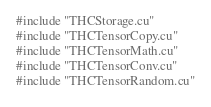<code> <loc_0><loc_0><loc_500><loc_500><_Cuda_>#include "THCStorage.cu"
#include "THCTensorCopy.cu"
#include "THCTensorMath.cu"
#include "THCTensorConv.cu"
#include "THCTensorRandom.cu"
</code> 